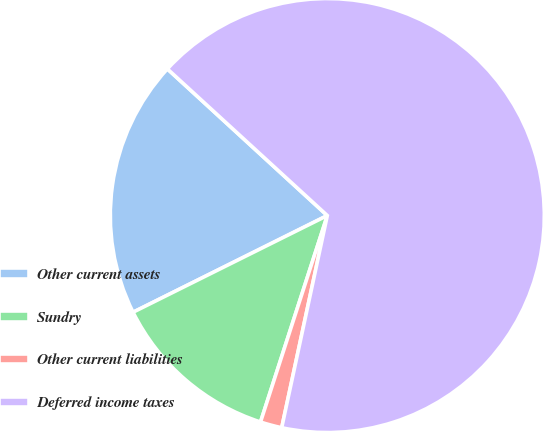Convert chart to OTSL. <chart><loc_0><loc_0><loc_500><loc_500><pie_chart><fcel>Other current assets<fcel>Sundry<fcel>Other current liabilities<fcel>Deferred income taxes<nl><fcel>19.16%<fcel>12.67%<fcel>1.61%<fcel>66.56%<nl></chart> 